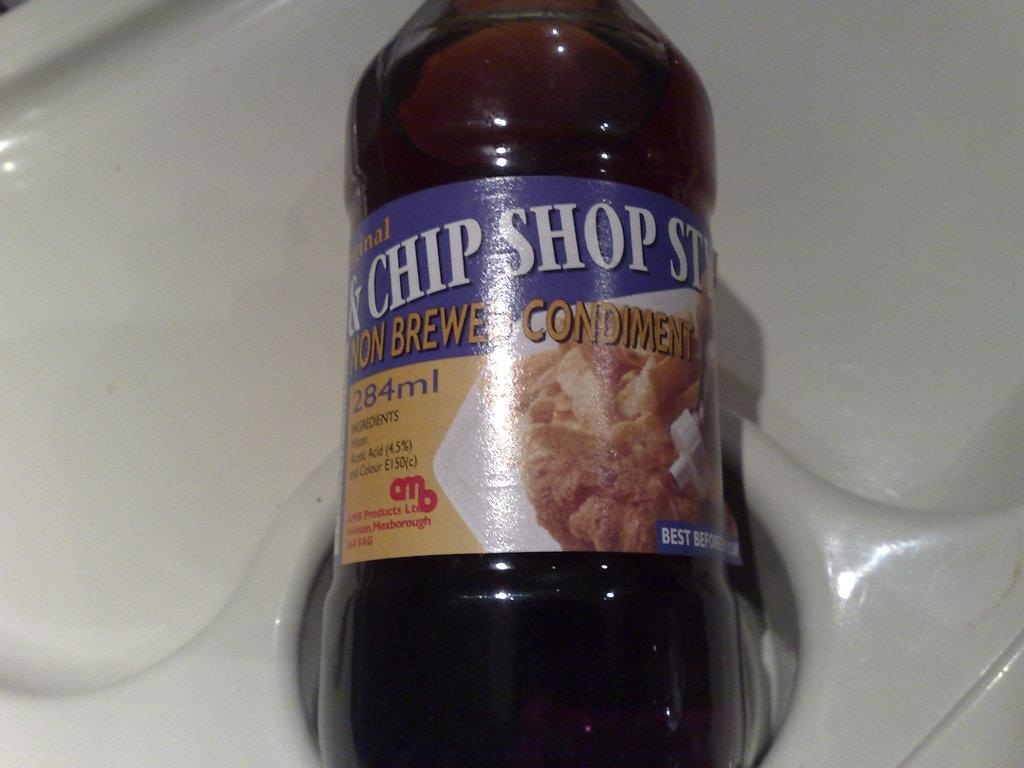<image>
Describe the image concisely. The sauce has 284ml of flavor that will go well with cooking. 